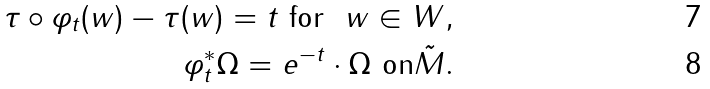Convert formula to latex. <formula><loc_0><loc_0><loc_500><loc_500>\tau \circ \varphi _ { t } ( w ) - \tau ( w ) = t \text {\ for } \ w \in W , \\ \varphi _ { t } ^ { * } \Omega = e ^ { - t } \cdot \Omega \text {\ on} \tilde { M } .</formula> 